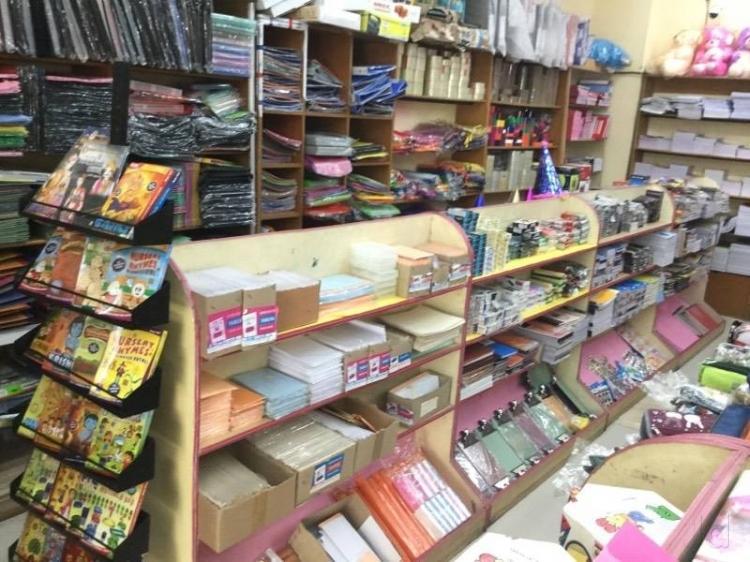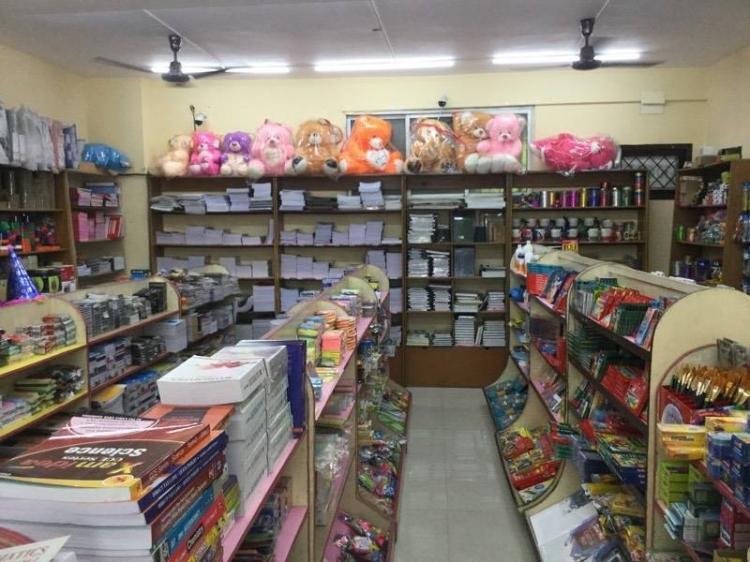The first image is the image on the left, the second image is the image on the right. Analyze the images presented: Is the assertion "People are looking at the merchandise." valid? Answer yes or no. No. The first image is the image on the left, the second image is the image on the right. Considering the images on both sides, is "In the book store there are at least 10 stuff bears ranging in color from pink, orange and purple sit on the top back self." valid? Answer yes or no. Yes. 